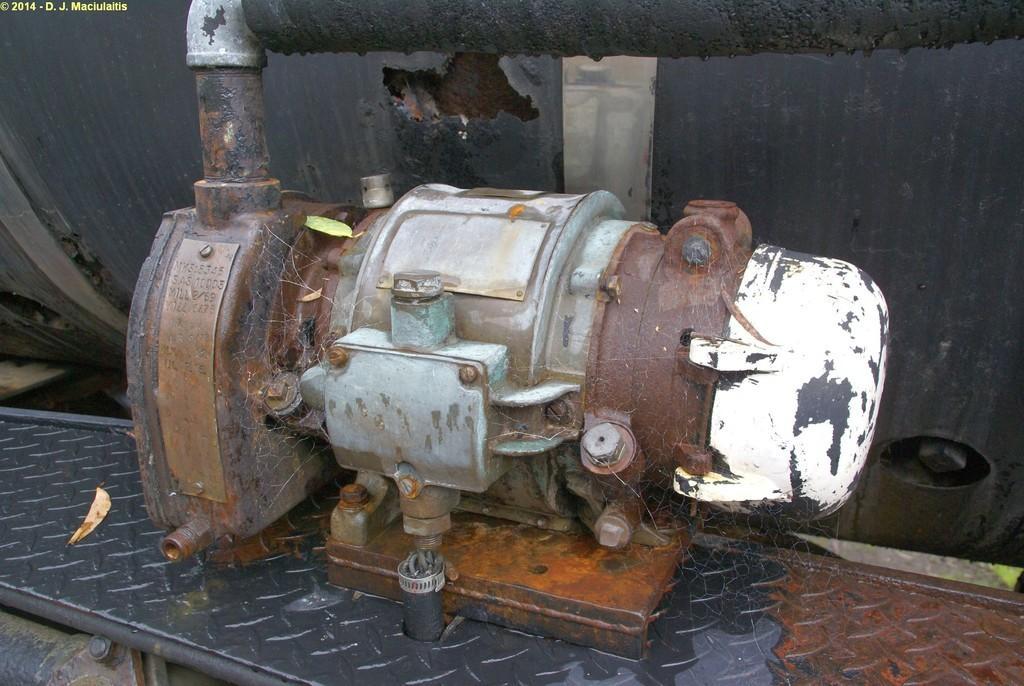Can you describe this image briefly? In this image I can see a motor. 